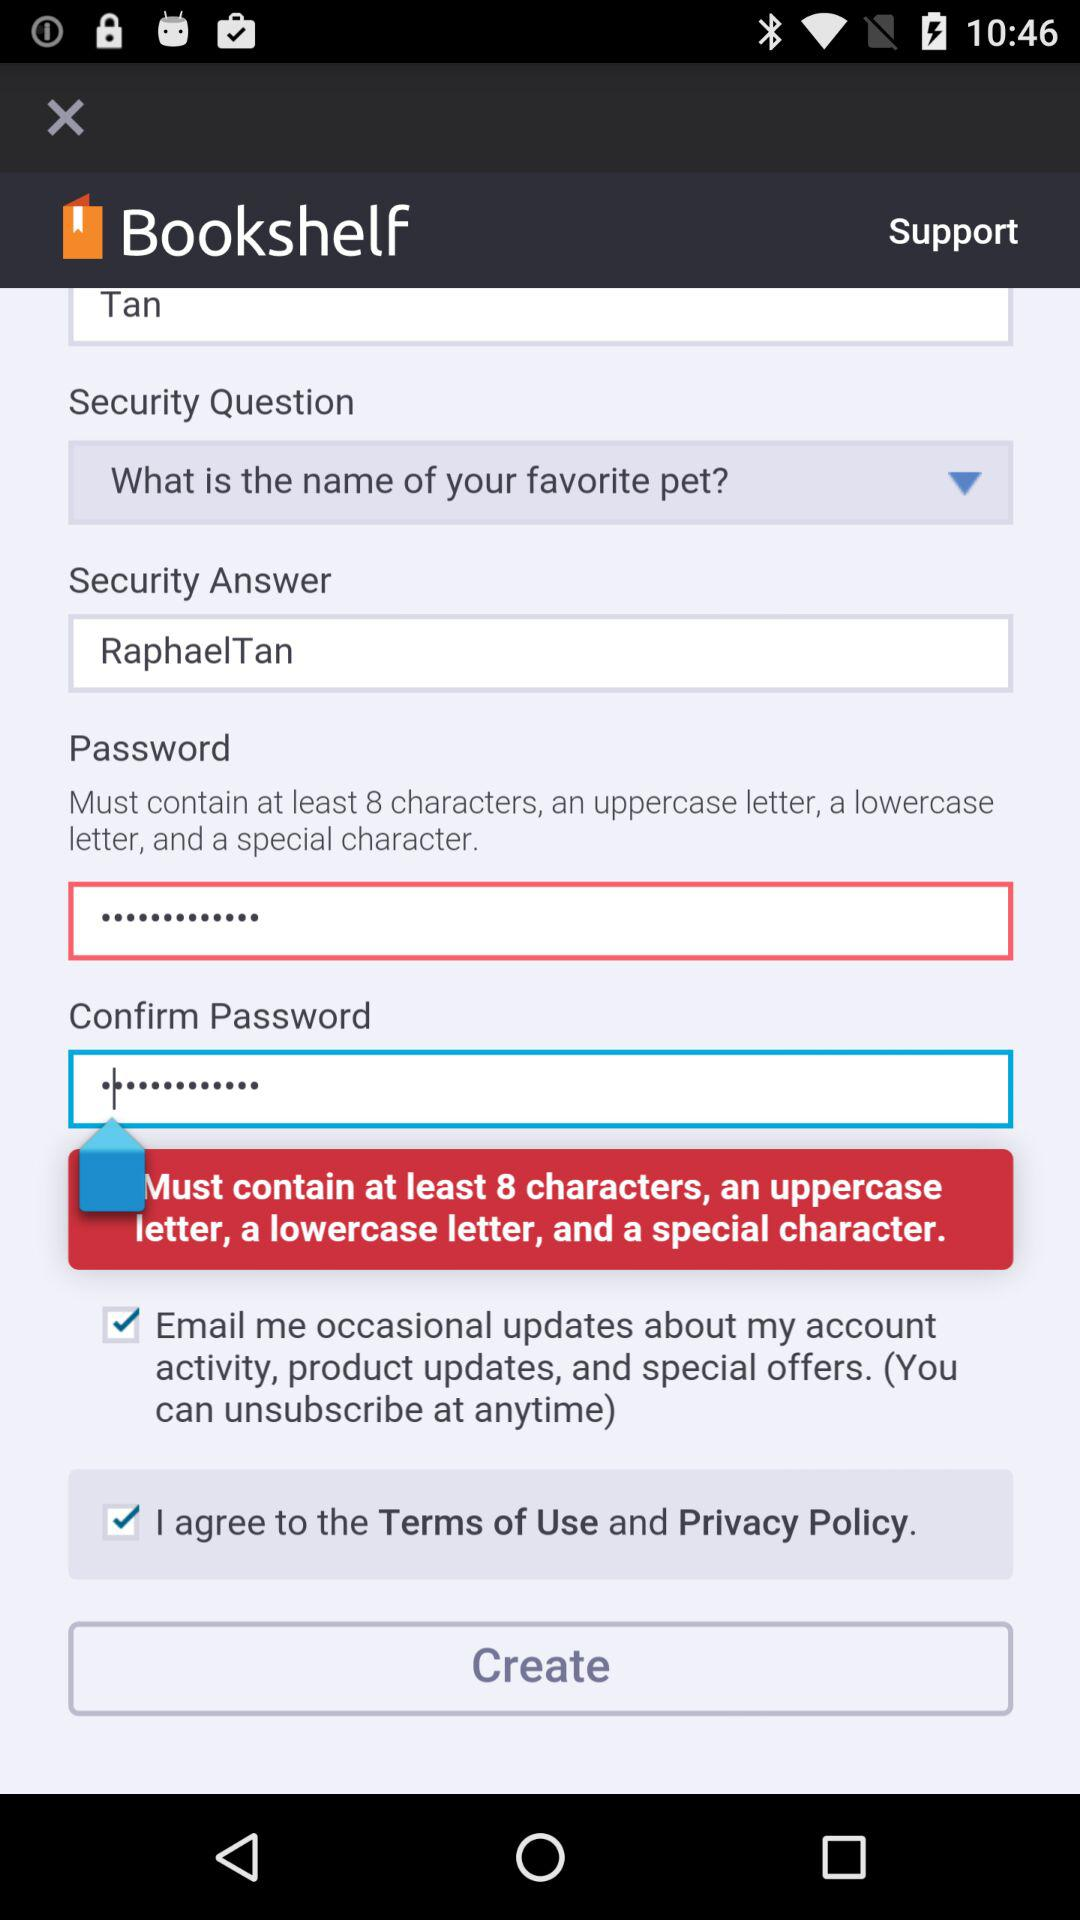What is the status of the option that includes agreement to the “Terms of Use” and "Privacy Policy"? The status of the option that includes agreement to the "Terms of Use" and "Privacy Policy" is "on". 